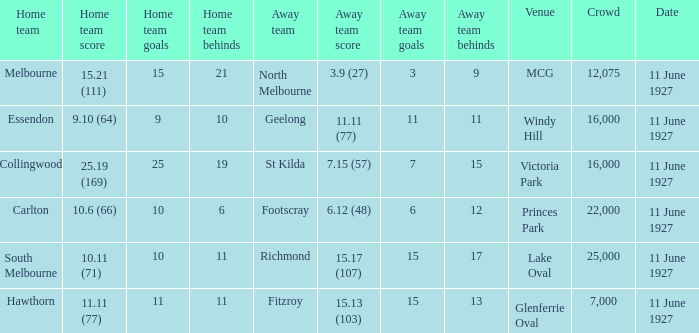What was the tally for the home team of essendon? 9.10 (64). 